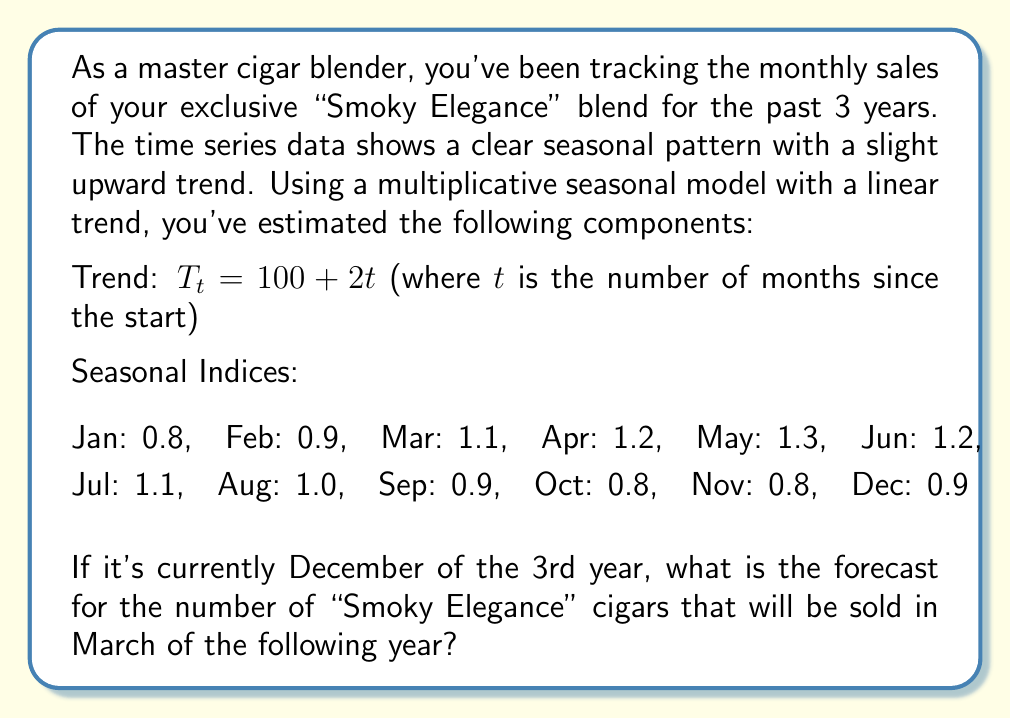Help me with this question. To solve this problem, we'll use the multiplicative seasonal model:

$$ Y_t = T_t \times S_t \times E_t $$

Where:
$Y_t$ is the forecast
$T_t$ is the trend component
$S_t$ is the seasonal component
$E_t$ is the error term (assumed to be 1 for forecasting)

Steps to solve:

1. Determine the value of $t$ for March of the following year:
   - December of 3rd year is month 36
   - March is 3 months later, so $t = 39$

2. Calculate the trend component $T_t$:
   $$ T_{39} = 100 + 2(39) = 178 $$

3. Identify the seasonal index for March:
   $S_{\text{March}} = 1.1$

4. Apply the multiplicative model:
   $$ Y_{39} = T_{39} \times S_{\text{March}} \times E_t $$
   $$ Y_{39} = 178 \times 1.1 \times 1 = 195.8 $$

5. Round to the nearest whole number, as we can't sell partial cigars.
Answer: 196 cigars 